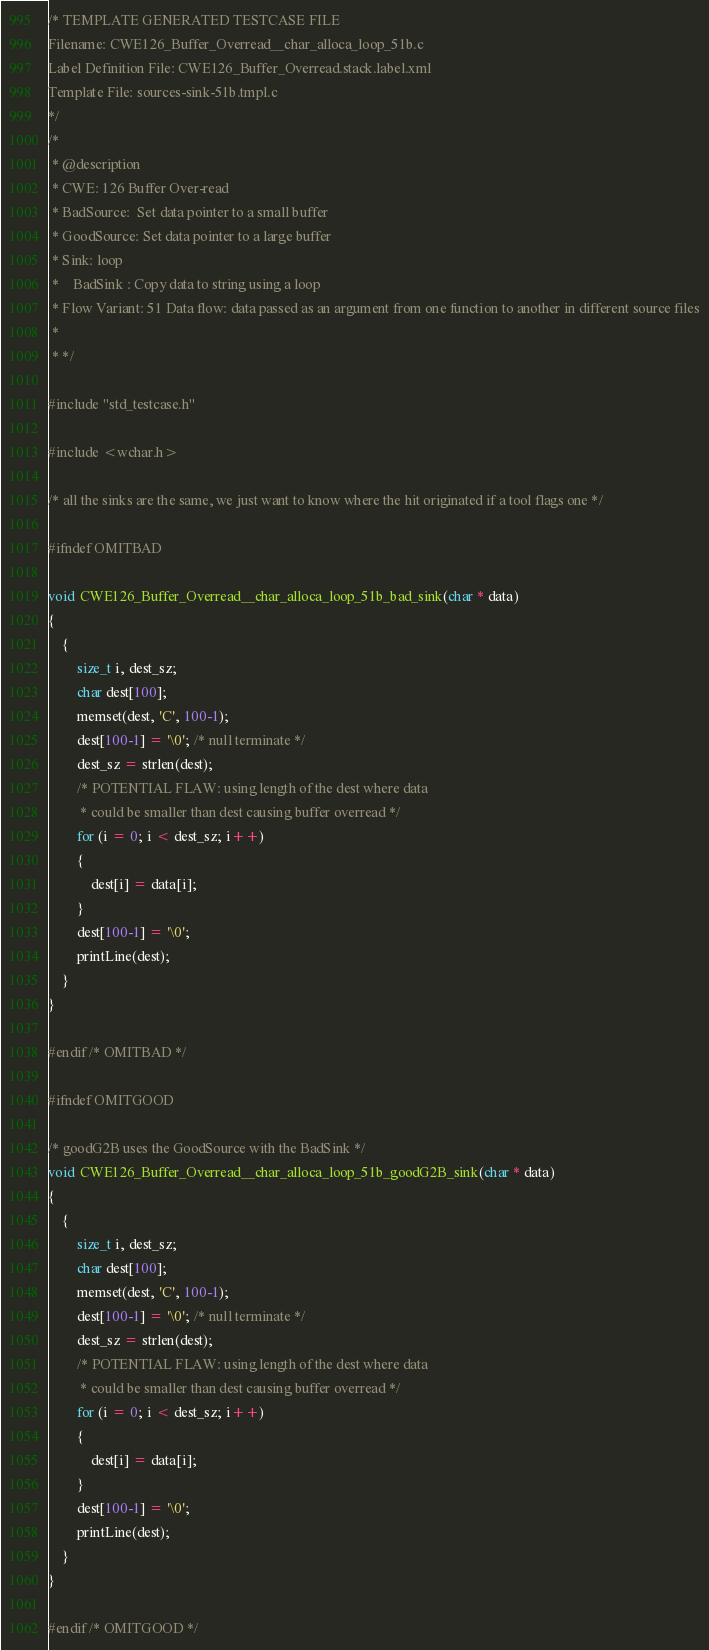<code> <loc_0><loc_0><loc_500><loc_500><_C_>/* TEMPLATE GENERATED TESTCASE FILE
Filename: CWE126_Buffer_Overread__char_alloca_loop_51b.c
Label Definition File: CWE126_Buffer_Overread.stack.label.xml
Template File: sources-sink-51b.tmpl.c
*/
/*
 * @description
 * CWE: 126 Buffer Over-read
 * BadSource:  Set data pointer to a small buffer
 * GoodSource: Set data pointer to a large buffer
 * Sink: loop
 *    BadSink : Copy data to string using a loop
 * Flow Variant: 51 Data flow: data passed as an argument from one function to another in different source files
 *
 * */

#include "std_testcase.h"

#include <wchar.h>

/* all the sinks are the same, we just want to know where the hit originated if a tool flags one */

#ifndef OMITBAD

void CWE126_Buffer_Overread__char_alloca_loop_51b_bad_sink(char * data)
{
    {
        size_t i, dest_sz;
        char dest[100];
        memset(dest, 'C', 100-1);
        dest[100-1] = '\0'; /* null terminate */
        dest_sz = strlen(dest);
        /* POTENTIAL FLAW: using length of the dest where data
         * could be smaller than dest causing buffer overread */
        for (i = 0; i < dest_sz; i++)
        {
            dest[i] = data[i];
        }
        dest[100-1] = '\0';
        printLine(dest);
    }
}

#endif /* OMITBAD */

#ifndef OMITGOOD

/* goodG2B uses the GoodSource with the BadSink */
void CWE126_Buffer_Overread__char_alloca_loop_51b_goodG2B_sink(char * data)
{
    {
        size_t i, dest_sz;
        char dest[100];
        memset(dest, 'C', 100-1);
        dest[100-1] = '\0'; /* null terminate */
        dest_sz = strlen(dest);
        /* POTENTIAL FLAW: using length of the dest where data
         * could be smaller than dest causing buffer overread */
        for (i = 0; i < dest_sz; i++)
        {
            dest[i] = data[i];
        }
        dest[100-1] = '\0';
        printLine(dest);
    }
}

#endif /* OMITGOOD */
</code> 